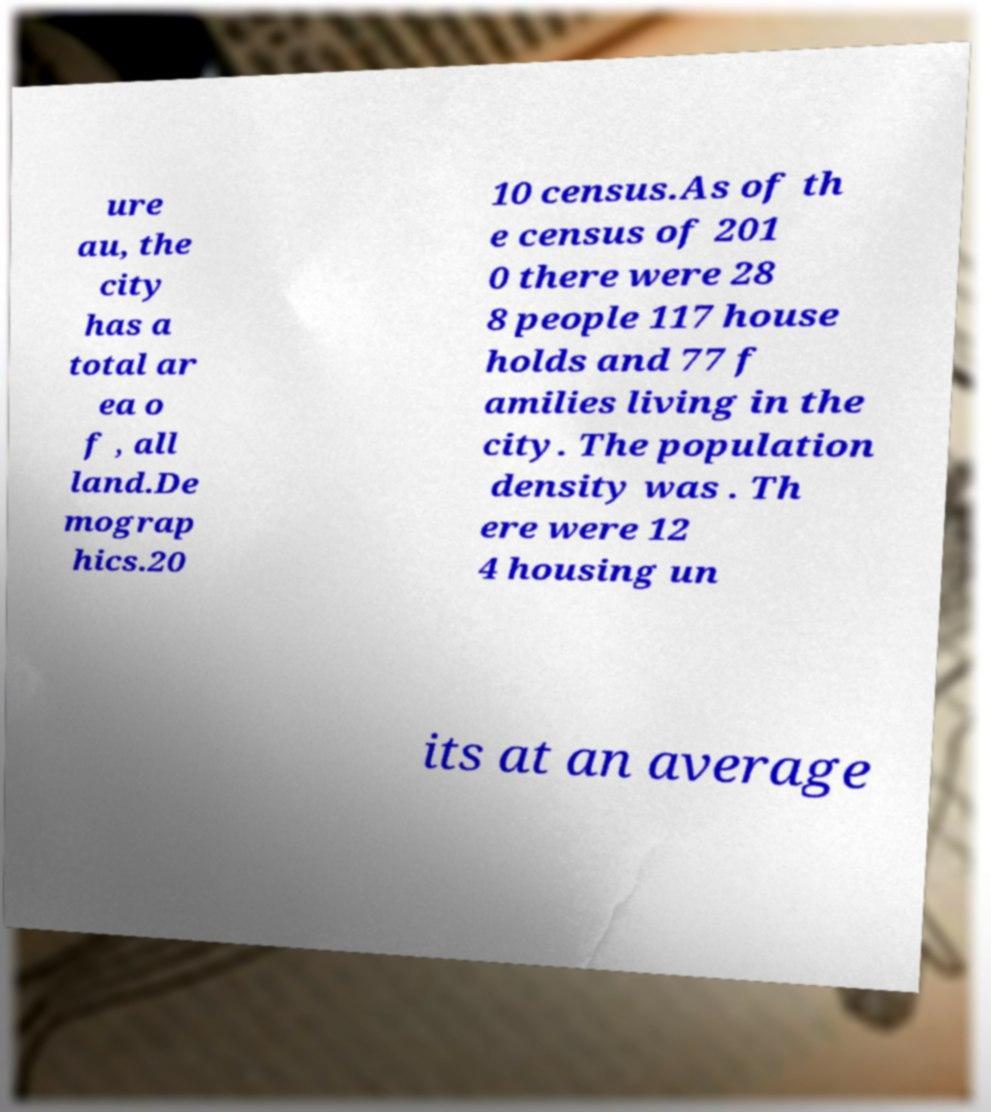Please identify and transcribe the text found in this image. ure au, the city has a total ar ea o f , all land.De mograp hics.20 10 census.As of th e census of 201 0 there were 28 8 people 117 house holds and 77 f amilies living in the city. The population density was . Th ere were 12 4 housing un its at an average 